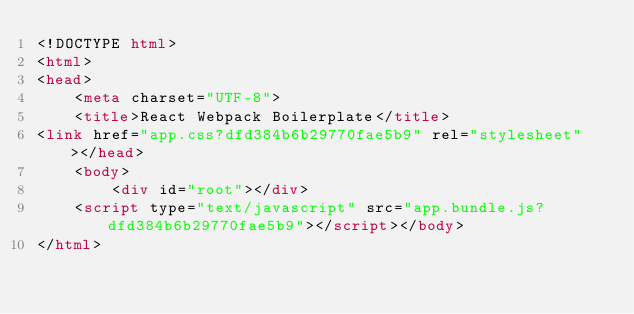<code> <loc_0><loc_0><loc_500><loc_500><_HTML_><!DOCTYPE html>
<html>
<head>
    <meta charset="UTF-8">
    <title>React Webpack Boilerplate</title>
<link href="app.css?dfd384b6b29770fae5b9" rel="stylesheet"></head>
    <body>
        <div id="root"></div>
    <script type="text/javascript" src="app.bundle.js?dfd384b6b29770fae5b9"></script></body>
</html></code> 